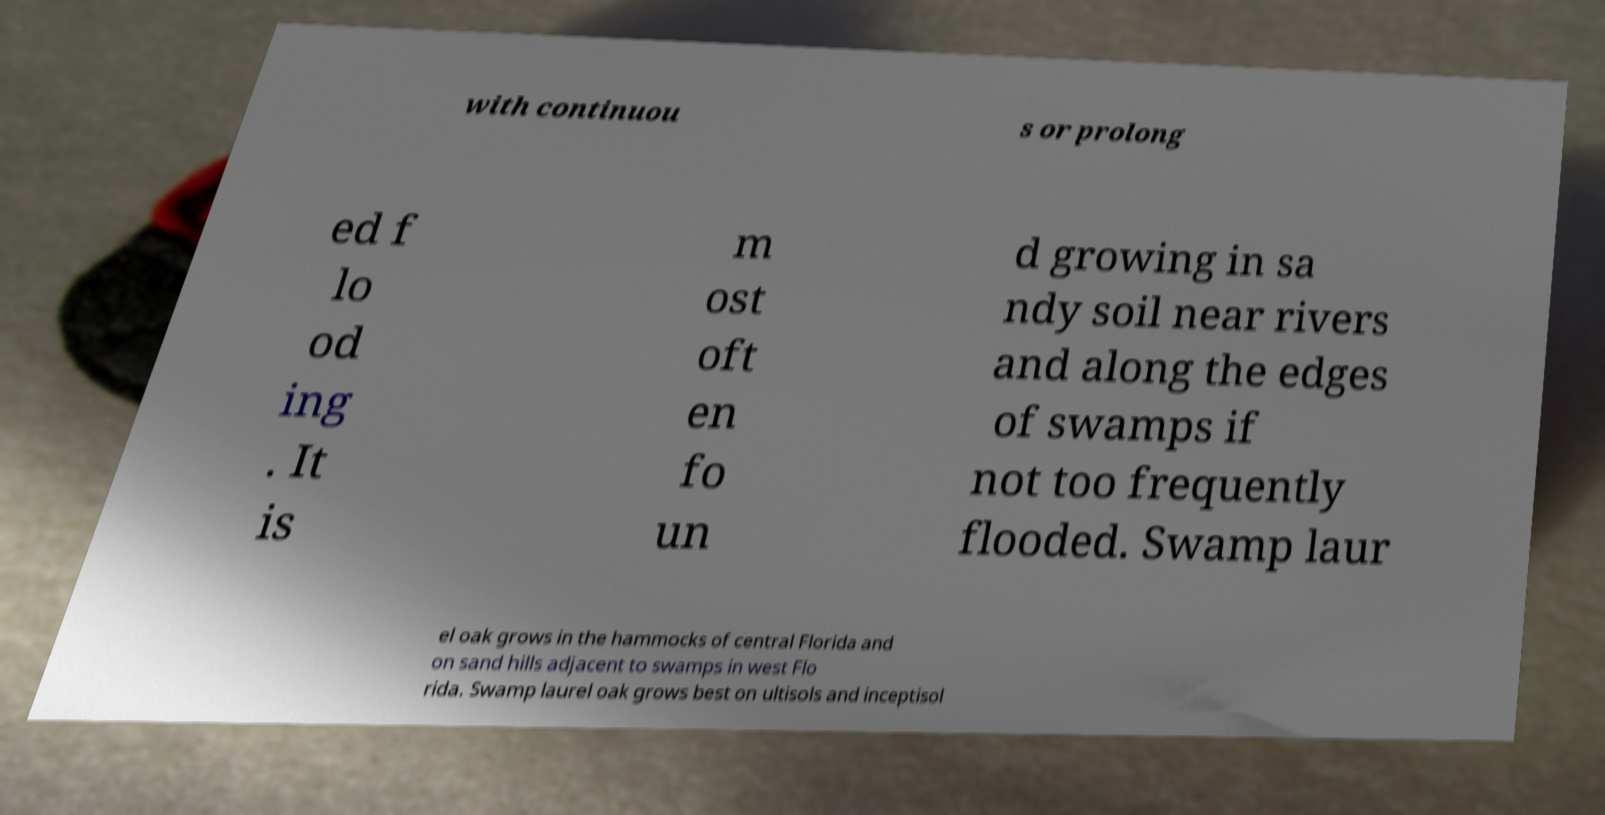Can you read and provide the text displayed in the image?This photo seems to have some interesting text. Can you extract and type it out for me? with continuou s or prolong ed f lo od ing . It is m ost oft en fo un d growing in sa ndy soil near rivers and along the edges of swamps if not too frequently flooded. Swamp laur el oak grows in the hammocks of central Florida and on sand hills adjacent to swamps in west Flo rida. Swamp laurel oak grows best on ultisols and inceptisol 